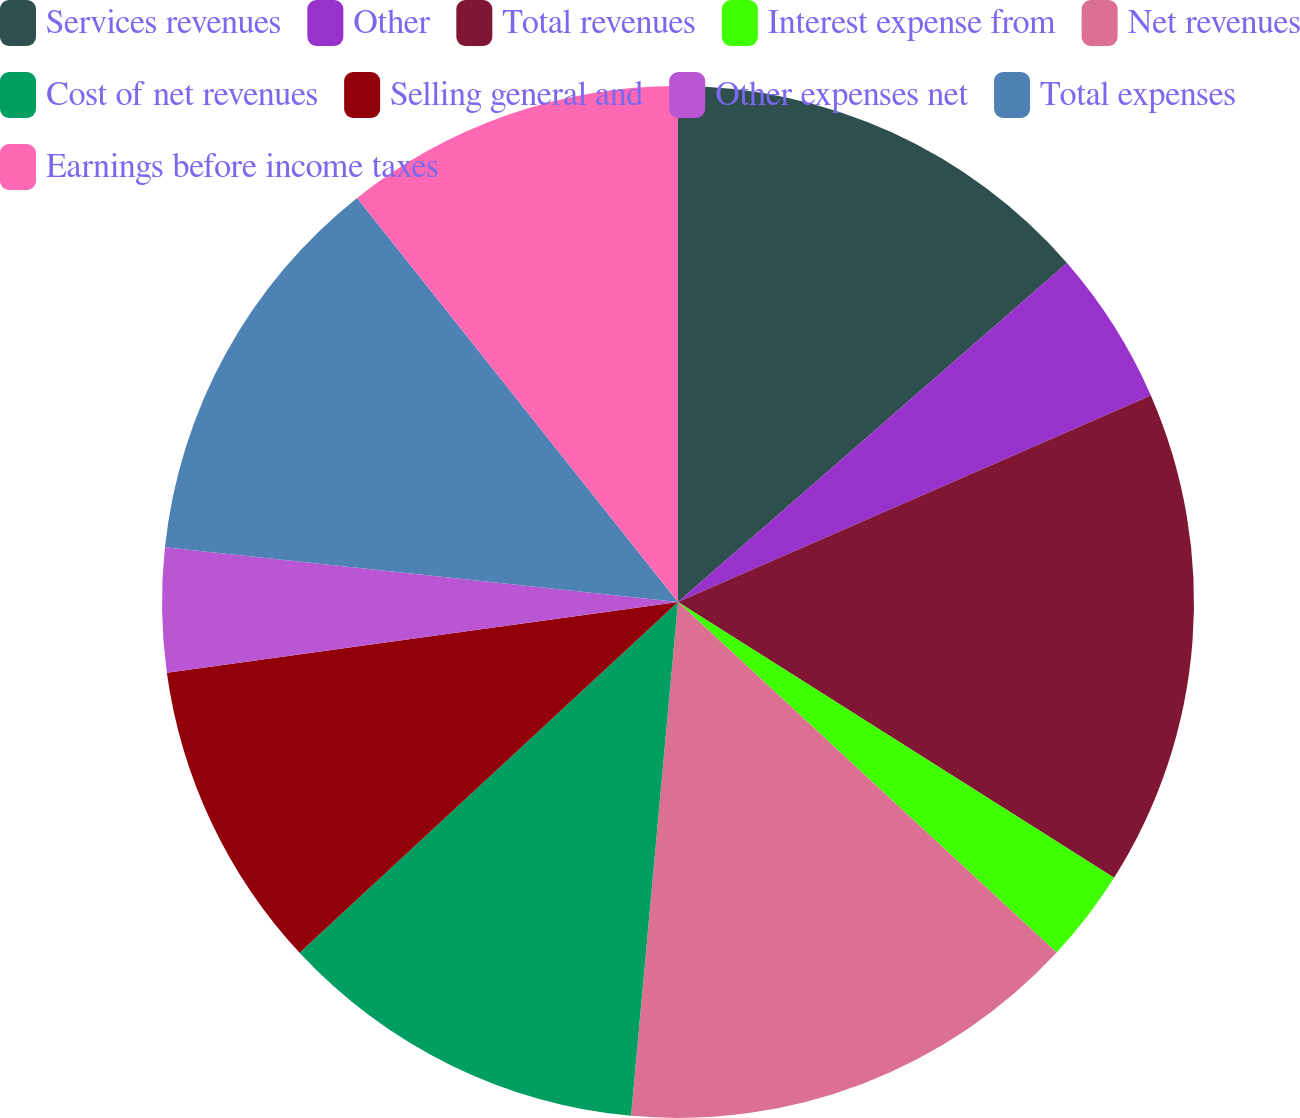Convert chart to OTSL. <chart><loc_0><loc_0><loc_500><loc_500><pie_chart><fcel>Services revenues<fcel>Other<fcel>Total revenues<fcel>Interest expense from<fcel>Net revenues<fcel>Cost of net revenues<fcel>Selling general and<fcel>Other expenses net<fcel>Total expenses<fcel>Earnings before income taxes<nl><fcel>13.59%<fcel>4.85%<fcel>15.53%<fcel>2.91%<fcel>14.56%<fcel>11.65%<fcel>9.71%<fcel>3.88%<fcel>12.62%<fcel>10.68%<nl></chart> 